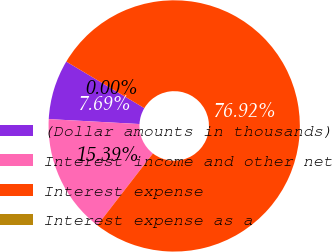Convert chart. <chart><loc_0><loc_0><loc_500><loc_500><pie_chart><fcel>(Dollar amounts in thousands)<fcel>Interest income and other net<fcel>Interest expense<fcel>Interest expense as a<nl><fcel>7.69%<fcel>15.39%<fcel>76.92%<fcel>0.0%<nl></chart> 